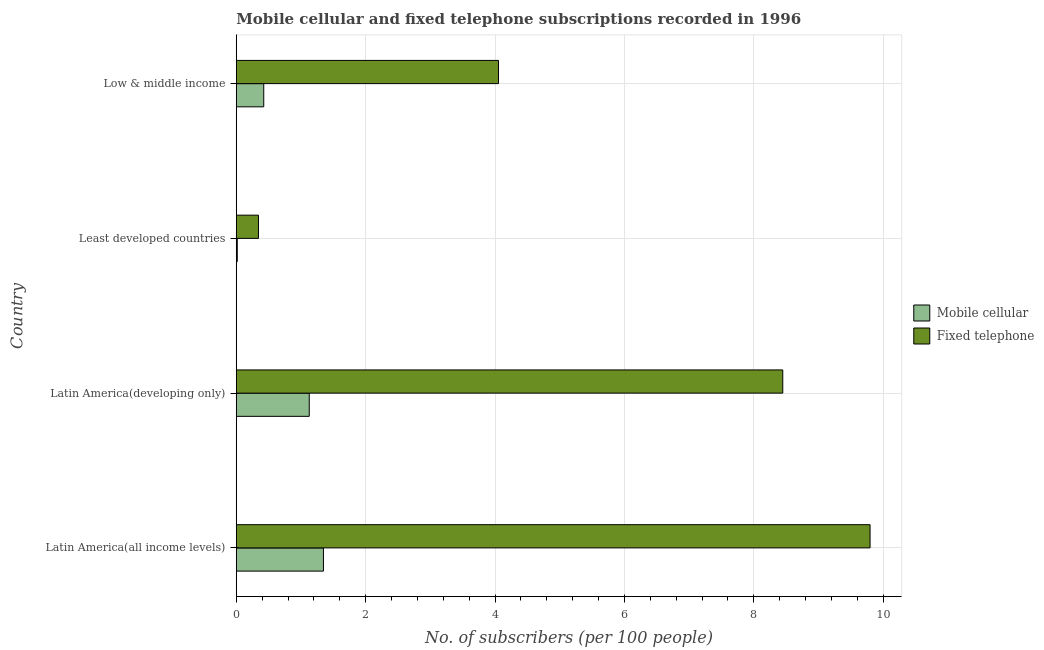Are the number of bars on each tick of the Y-axis equal?
Make the answer very short. Yes. How many bars are there on the 3rd tick from the top?
Your answer should be very brief. 2. How many bars are there on the 2nd tick from the bottom?
Keep it short and to the point. 2. What is the label of the 4th group of bars from the top?
Provide a succinct answer. Latin America(all income levels). In how many cases, is the number of bars for a given country not equal to the number of legend labels?
Offer a very short reply. 0. What is the number of fixed telephone subscribers in Latin America(all income levels)?
Offer a terse response. 9.8. Across all countries, what is the maximum number of fixed telephone subscribers?
Your response must be concise. 9.8. Across all countries, what is the minimum number of fixed telephone subscribers?
Give a very brief answer. 0.34. In which country was the number of mobile cellular subscribers maximum?
Keep it short and to the point. Latin America(all income levels). In which country was the number of mobile cellular subscribers minimum?
Offer a very short reply. Least developed countries. What is the total number of fixed telephone subscribers in the graph?
Keep it short and to the point. 22.64. What is the difference between the number of mobile cellular subscribers in Latin America(all income levels) and that in Least developed countries?
Provide a succinct answer. 1.33. What is the difference between the number of mobile cellular subscribers in Low & middle income and the number of fixed telephone subscribers in Latin America(developing only)?
Provide a short and direct response. -8.02. What is the average number of fixed telephone subscribers per country?
Offer a very short reply. 5.66. What is the difference between the number of mobile cellular subscribers and number of fixed telephone subscribers in Latin America(all income levels)?
Provide a succinct answer. -8.45. In how many countries, is the number of fixed telephone subscribers greater than 3.2 ?
Provide a short and direct response. 3. What is the ratio of the number of fixed telephone subscribers in Latin America(all income levels) to that in Latin America(developing only)?
Your answer should be compact. 1.16. What is the difference between the highest and the second highest number of fixed telephone subscribers?
Make the answer very short. 1.35. What is the difference between the highest and the lowest number of mobile cellular subscribers?
Provide a short and direct response. 1.33. In how many countries, is the number of fixed telephone subscribers greater than the average number of fixed telephone subscribers taken over all countries?
Offer a very short reply. 2. What does the 1st bar from the top in Low & middle income represents?
Provide a succinct answer. Fixed telephone. What does the 1st bar from the bottom in Latin America(developing only) represents?
Make the answer very short. Mobile cellular. What is the difference between two consecutive major ticks on the X-axis?
Offer a terse response. 2. Does the graph contain any zero values?
Provide a succinct answer. No. How many legend labels are there?
Keep it short and to the point. 2. How are the legend labels stacked?
Ensure brevity in your answer.  Vertical. What is the title of the graph?
Give a very brief answer. Mobile cellular and fixed telephone subscriptions recorded in 1996. Does "RDB nonconcessional" appear as one of the legend labels in the graph?
Provide a succinct answer. No. What is the label or title of the X-axis?
Your answer should be very brief. No. of subscribers (per 100 people). What is the No. of subscribers (per 100 people) in Mobile cellular in Latin America(all income levels)?
Your response must be concise. 1.35. What is the No. of subscribers (per 100 people) of Fixed telephone in Latin America(all income levels)?
Your answer should be very brief. 9.8. What is the No. of subscribers (per 100 people) in Mobile cellular in Latin America(developing only)?
Your answer should be very brief. 1.13. What is the No. of subscribers (per 100 people) in Fixed telephone in Latin America(developing only)?
Your answer should be compact. 8.45. What is the No. of subscribers (per 100 people) in Mobile cellular in Least developed countries?
Keep it short and to the point. 0.02. What is the No. of subscribers (per 100 people) of Fixed telephone in Least developed countries?
Provide a short and direct response. 0.34. What is the No. of subscribers (per 100 people) in Mobile cellular in Low & middle income?
Offer a terse response. 0.43. What is the No. of subscribers (per 100 people) of Fixed telephone in Low & middle income?
Offer a terse response. 4.05. Across all countries, what is the maximum No. of subscribers (per 100 people) of Mobile cellular?
Your answer should be very brief. 1.35. Across all countries, what is the maximum No. of subscribers (per 100 people) of Fixed telephone?
Your answer should be compact. 9.8. Across all countries, what is the minimum No. of subscribers (per 100 people) in Mobile cellular?
Give a very brief answer. 0.02. Across all countries, what is the minimum No. of subscribers (per 100 people) of Fixed telephone?
Offer a terse response. 0.34. What is the total No. of subscribers (per 100 people) of Mobile cellular in the graph?
Make the answer very short. 2.92. What is the total No. of subscribers (per 100 people) in Fixed telephone in the graph?
Your answer should be very brief. 22.64. What is the difference between the No. of subscribers (per 100 people) of Mobile cellular in Latin America(all income levels) and that in Latin America(developing only)?
Your answer should be very brief. 0.22. What is the difference between the No. of subscribers (per 100 people) in Fixed telephone in Latin America(all income levels) and that in Latin America(developing only)?
Your response must be concise. 1.35. What is the difference between the No. of subscribers (per 100 people) in Mobile cellular in Latin America(all income levels) and that in Least developed countries?
Provide a short and direct response. 1.33. What is the difference between the No. of subscribers (per 100 people) of Fixed telephone in Latin America(all income levels) and that in Least developed countries?
Provide a short and direct response. 9.45. What is the difference between the No. of subscribers (per 100 people) of Mobile cellular in Latin America(all income levels) and that in Low & middle income?
Provide a short and direct response. 0.92. What is the difference between the No. of subscribers (per 100 people) of Fixed telephone in Latin America(all income levels) and that in Low & middle income?
Make the answer very short. 5.74. What is the difference between the No. of subscribers (per 100 people) of Mobile cellular in Latin America(developing only) and that in Least developed countries?
Offer a terse response. 1.11. What is the difference between the No. of subscribers (per 100 people) in Fixed telephone in Latin America(developing only) and that in Least developed countries?
Give a very brief answer. 8.1. What is the difference between the No. of subscribers (per 100 people) of Mobile cellular in Latin America(developing only) and that in Low & middle income?
Offer a terse response. 0.7. What is the difference between the No. of subscribers (per 100 people) of Fixed telephone in Latin America(developing only) and that in Low & middle income?
Provide a short and direct response. 4.39. What is the difference between the No. of subscribers (per 100 people) in Mobile cellular in Least developed countries and that in Low & middle income?
Provide a short and direct response. -0.41. What is the difference between the No. of subscribers (per 100 people) of Fixed telephone in Least developed countries and that in Low & middle income?
Offer a very short reply. -3.71. What is the difference between the No. of subscribers (per 100 people) of Mobile cellular in Latin America(all income levels) and the No. of subscribers (per 100 people) of Fixed telephone in Latin America(developing only)?
Provide a short and direct response. -7.1. What is the difference between the No. of subscribers (per 100 people) of Mobile cellular in Latin America(all income levels) and the No. of subscribers (per 100 people) of Fixed telephone in Least developed countries?
Provide a succinct answer. 1. What is the difference between the No. of subscribers (per 100 people) of Mobile cellular in Latin America(all income levels) and the No. of subscribers (per 100 people) of Fixed telephone in Low & middle income?
Make the answer very short. -2.71. What is the difference between the No. of subscribers (per 100 people) of Mobile cellular in Latin America(developing only) and the No. of subscribers (per 100 people) of Fixed telephone in Least developed countries?
Your answer should be very brief. 0.79. What is the difference between the No. of subscribers (per 100 people) of Mobile cellular in Latin America(developing only) and the No. of subscribers (per 100 people) of Fixed telephone in Low & middle income?
Offer a terse response. -2.92. What is the difference between the No. of subscribers (per 100 people) in Mobile cellular in Least developed countries and the No. of subscribers (per 100 people) in Fixed telephone in Low & middle income?
Your answer should be very brief. -4.04. What is the average No. of subscribers (per 100 people) of Mobile cellular per country?
Your answer should be compact. 0.73. What is the average No. of subscribers (per 100 people) in Fixed telephone per country?
Keep it short and to the point. 5.66. What is the difference between the No. of subscribers (per 100 people) in Mobile cellular and No. of subscribers (per 100 people) in Fixed telephone in Latin America(all income levels)?
Give a very brief answer. -8.45. What is the difference between the No. of subscribers (per 100 people) of Mobile cellular and No. of subscribers (per 100 people) of Fixed telephone in Latin America(developing only)?
Offer a terse response. -7.32. What is the difference between the No. of subscribers (per 100 people) of Mobile cellular and No. of subscribers (per 100 people) of Fixed telephone in Least developed countries?
Your answer should be very brief. -0.33. What is the difference between the No. of subscribers (per 100 people) in Mobile cellular and No. of subscribers (per 100 people) in Fixed telephone in Low & middle income?
Offer a very short reply. -3.63. What is the ratio of the No. of subscribers (per 100 people) in Mobile cellular in Latin America(all income levels) to that in Latin America(developing only)?
Offer a very short reply. 1.19. What is the ratio of the No. of subscribers (per 100 people) in Fixed telephone in Latin America(all income levels) to that in Latin America(developing only)?
Offer a terse response. 1.16. What is the ratio of the No. of subscribers (per 100 people) in Mobile cellular in Latin America(all income levels) to that in Least developed countries?
Offer a very short reply. 85.19. What is the ratio of the No. of subscribers (per 100 people) of Fixed telephone in Latin America(all income levels) to that in Least developed countries?
Your response must be concise. 28.54. What is the ratio of the No. of subscribers (per 100 people) of Mobile cellular in Latin America(all income levels) to that in Low & middle income?
Your answer should be compact. 3.17. What is the ratio of the No. of subscribers (per 100 people) in Fixed telephone in Latin America(all income levels) to that in Low & middle income?
Provide a short and direct response. 2.42. What is the ratio of the No. of subscribers (per 100 people) in Mobile cellular in Latin America(developing only) to that in Least developed countries?
Ensure brevity in your answer.  71.32. What is the ratio of the No. of subscribers (per 100 people) in Fixed telephone in Latin America(developing only) to that in Least developed countries?
Provide a short and direct response. 24.61. What is the ratio of the No. of subscribers (per 100 people) in Mobile cellular in Latin America(developing only) to that in Low & middle income?
Your answer should be very brief. 2.65. What is the ratio of the No. of subscribers (per 100 people) of Fixed telephone in Latin America(developing only) to that in Low & middle income?
Your response must be concise. 2.08. What is the ratio of the No. of subscribers (per 100 people) in Mobile cellular in Least developed countries to that in Low & middle income?
Give a very brief answer. 0.04. What is the ratio of the No. of subscribers (per 100 people) of Fixed telephone in Least developed countries to that in Low & middle income?
Give a very brief answer. 0.08. What is the difference between the highest and the second highest No. of subscribers (per 100 people) in Mobile cellular?
Offer a terse response. 0.22. What is the difference between the highest and the second highest No. of subscribers (per 100 people) in Fixed telephone?
Make the answer very short. 1.35. What is the difference between the highest and the lowest No. of subscribers (per 100 people) of Mobile cellular?
Your answer should be very brief. 1.33. What is the difference between the highest and the lowest No. of subscribers (per 100 people) in Fixed telephone?
Provide a succinct answer. 9.45. 